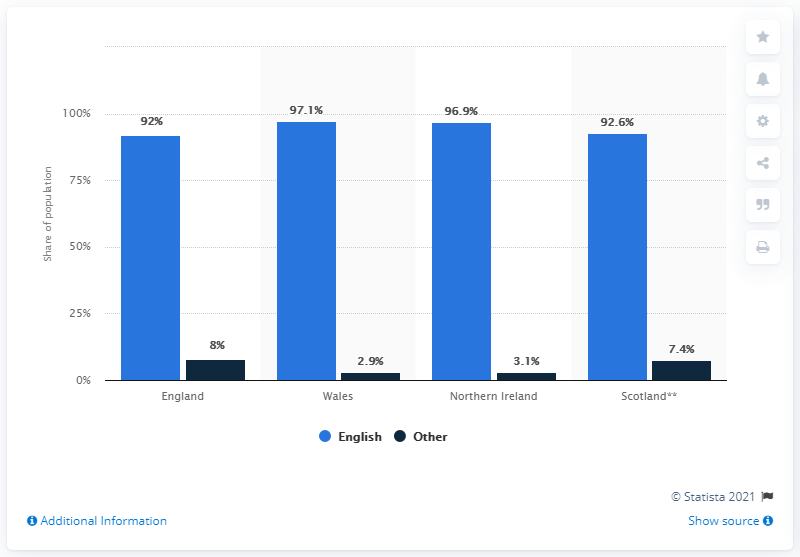Give some essential details in this illustration. The main language spoken by the population of the United Kingdom in 2011 was English. The average of the dark blue bar is 5.35. The value of the first blue bar, read left to right, is 92. Wales had a lower percentage of non-English speakers than any other country. 